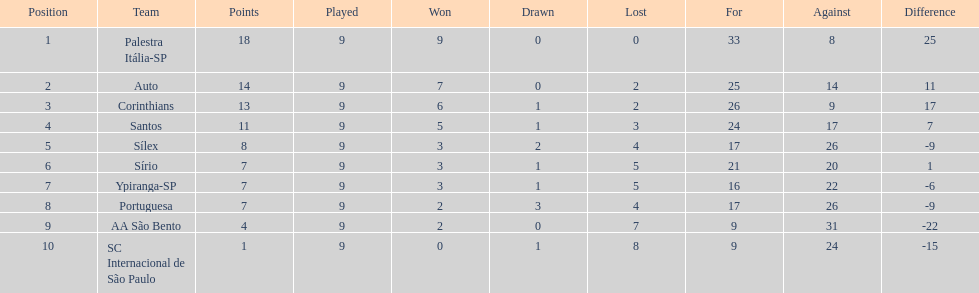What was the number of points the brazilian football team received automatically in 1926? 14. Can you give me this table as a dict? {'header': ['Position', 'Team', 'Points', 'Played', 'Won', 'Drawn', 'Lost', 'For', 'Against', 'Difference'], 'rows': [['1', 'Palestra Itália-SP', '18', '9', '9', '0', '0', '33', '8', '25'], ['2', 'Auto', '14', '9', '7', '0', '2', '25', '14', '11'], ['3', 'Corinthians', '13', '9', '6', '1', '2', '26', '9', '17'], ['4', 'Santos', '11', '9', '5', '1', '3', '24', '17', '7'], ['5', 'Sílex', '8', '9', '3', '2', '4', '17', '26', '-9'], ['6', 'Sírio', '7', '9', '3', '1', '5', '21', '20', '1'], ['7', 'Ypiranga-SP', '7', '9', '3', '1', '5', '16', '22', '-6'], ['8', 'Portuguesa', '7', '9', '2', '3', '4', '17', '26', '-9'], ['9', 'AA São Bento', '4', '9', '2', '0', '7', '9', '31', '-22'], ['10', 'SC Internacional de São Paulo', '1', '9', '0', '1', '8', '9', '24', '-15']]} 